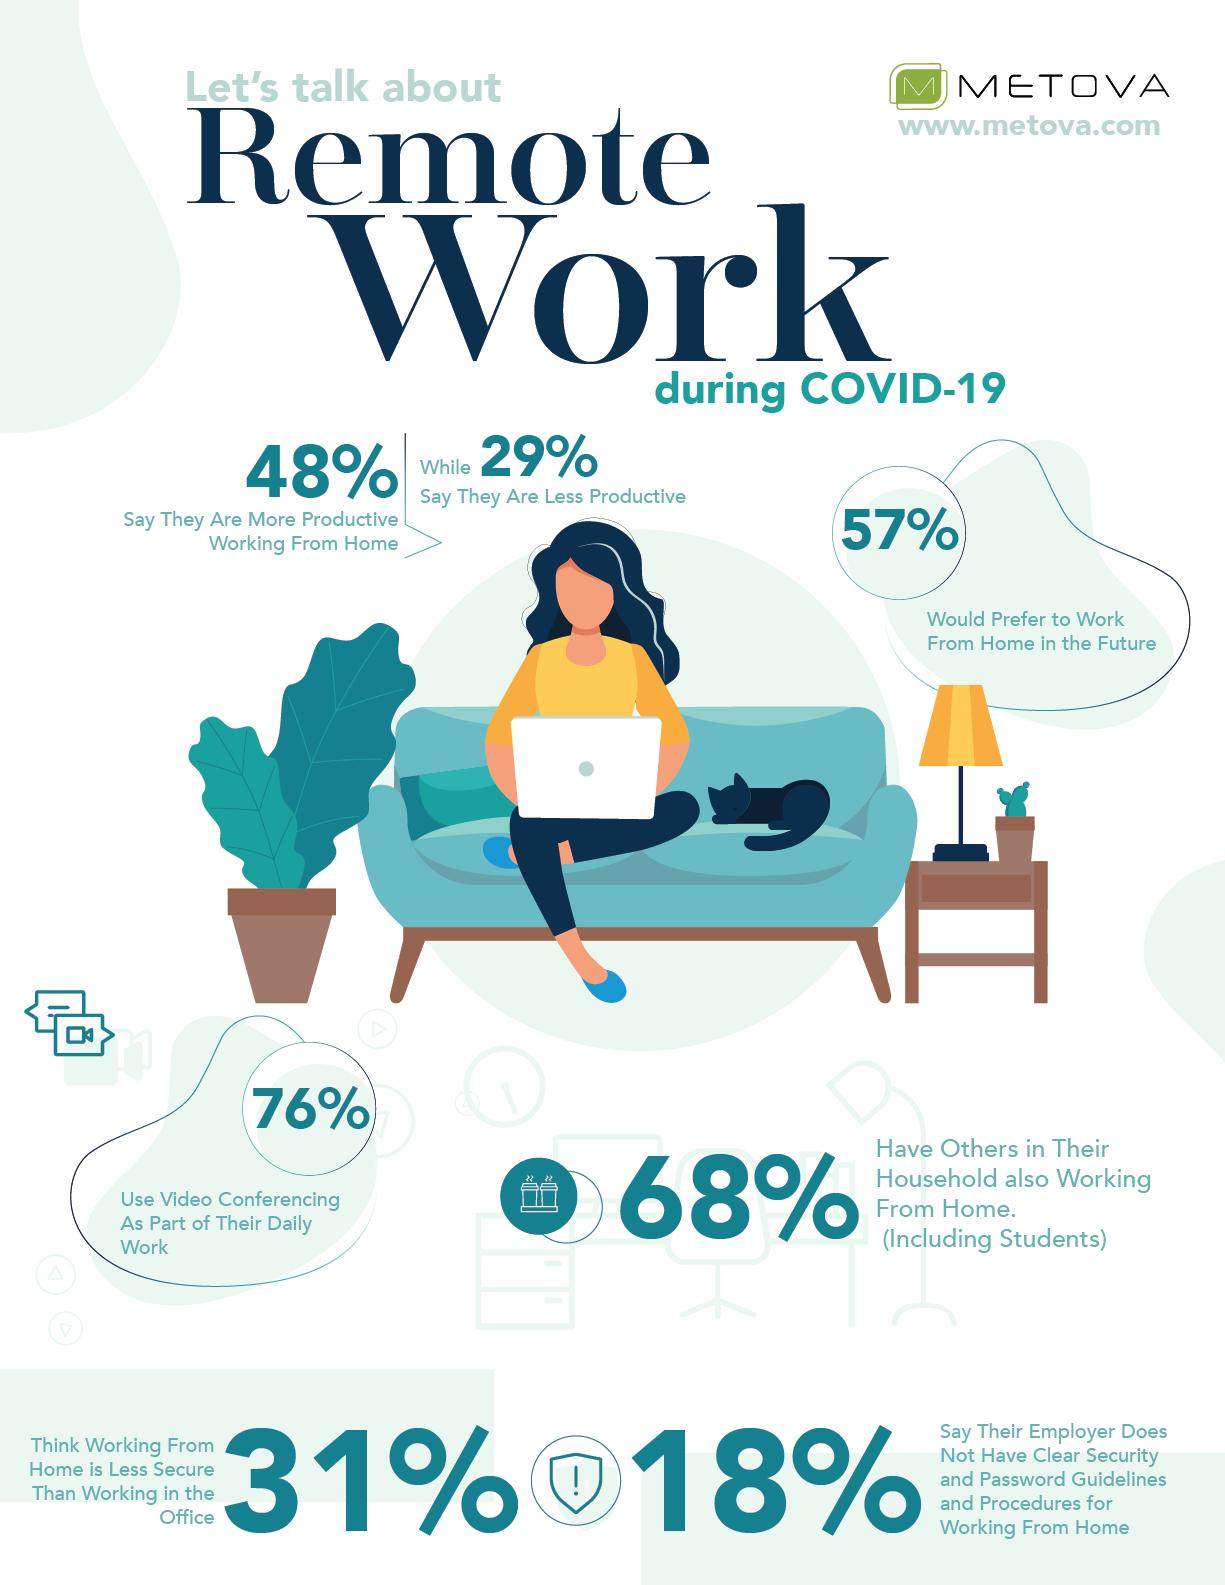Identify some key points in this picture. A recent survey revealed that 43% of people do not prefer to work from home in the future. Approximately 24% of people do not utilize video conferencing as part of their daily work. According to a recent survey, 48% of people believe that they are more productive when working from home during the COVID-19 pandemic. 